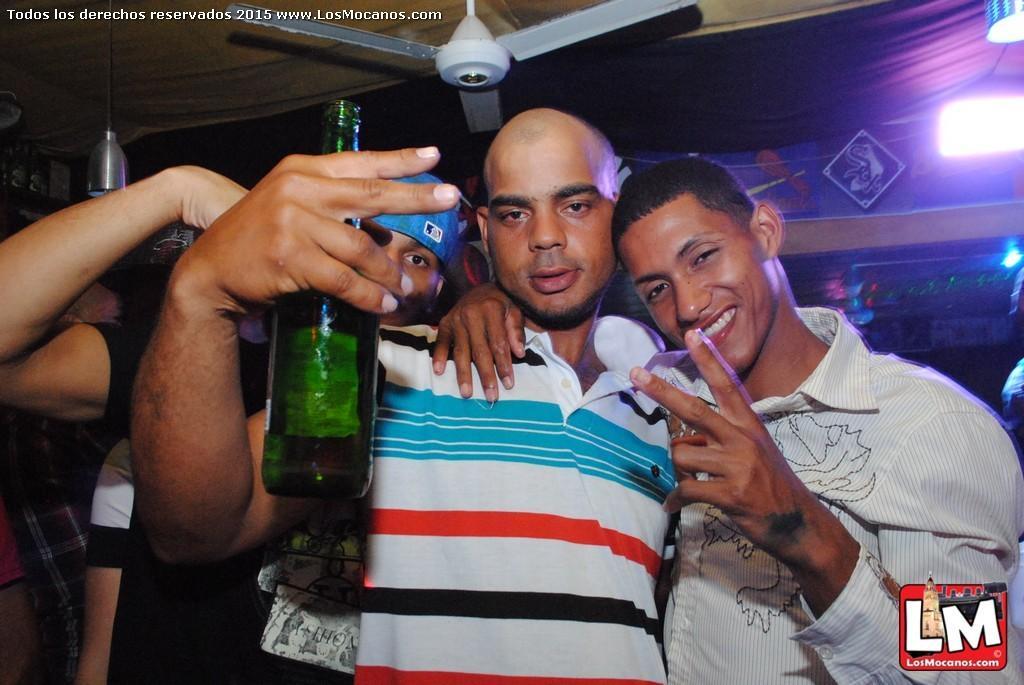Could you give a brief overview of what you see in this image? On the bottom right, there is a watermark. In the middle of this image, there are three persons in different color dresses. One of them is holding a green color bottle. In the background, there is a fan, there are lights, other persons and there are other objects. 